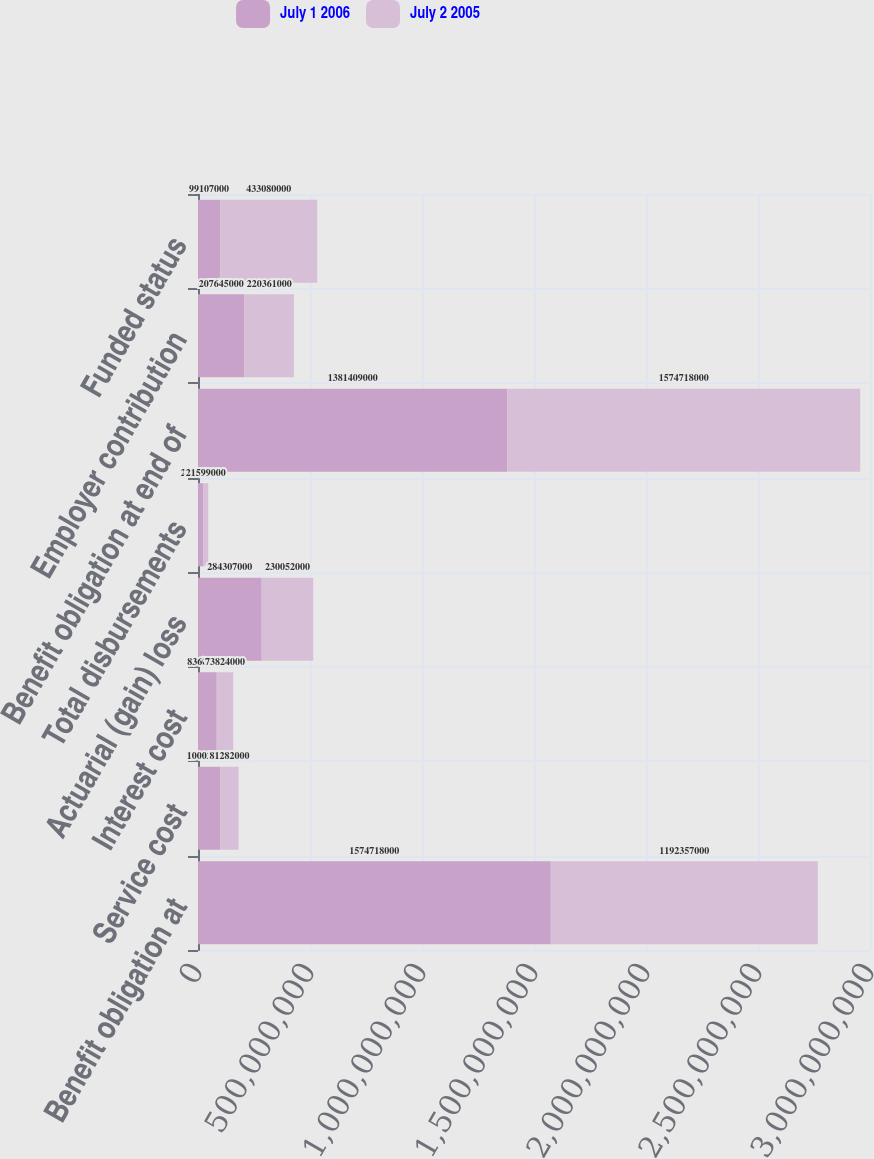<chart> <loc_0><loc_0><loc_500><loc_500><stacked_bar_chart><ecel><fcel>Benefit obligation at<fcel>Service cost<fcel>Interest cost<fcel>Actuarial (gain) loss<fcel>Total disbursements<fcel>Benefit obligation at end of<fcel>Employer contribution<fcel>Funded status<nl><fcel>July 1 2006<fcel>1.57472e+09<fcel>1.00028e+08<fcel>8.36e+07<fcel>2.84307e+08<fcel>2.4331e+07<fcel>1.38141e+09<fcel>2.07645e+08<fcel>9.9107e+07<nl><fcel>July 2 2005<fcel>1.19236e+09<fcel>8.1282e+07<fcel>7.3824e+07<fcel>2.30052e+08<fcel>2.1599e+07<fcel>1.57472e+09<fcel>2.20361e+08<fcel>4.3308e+08<nl></chart> 